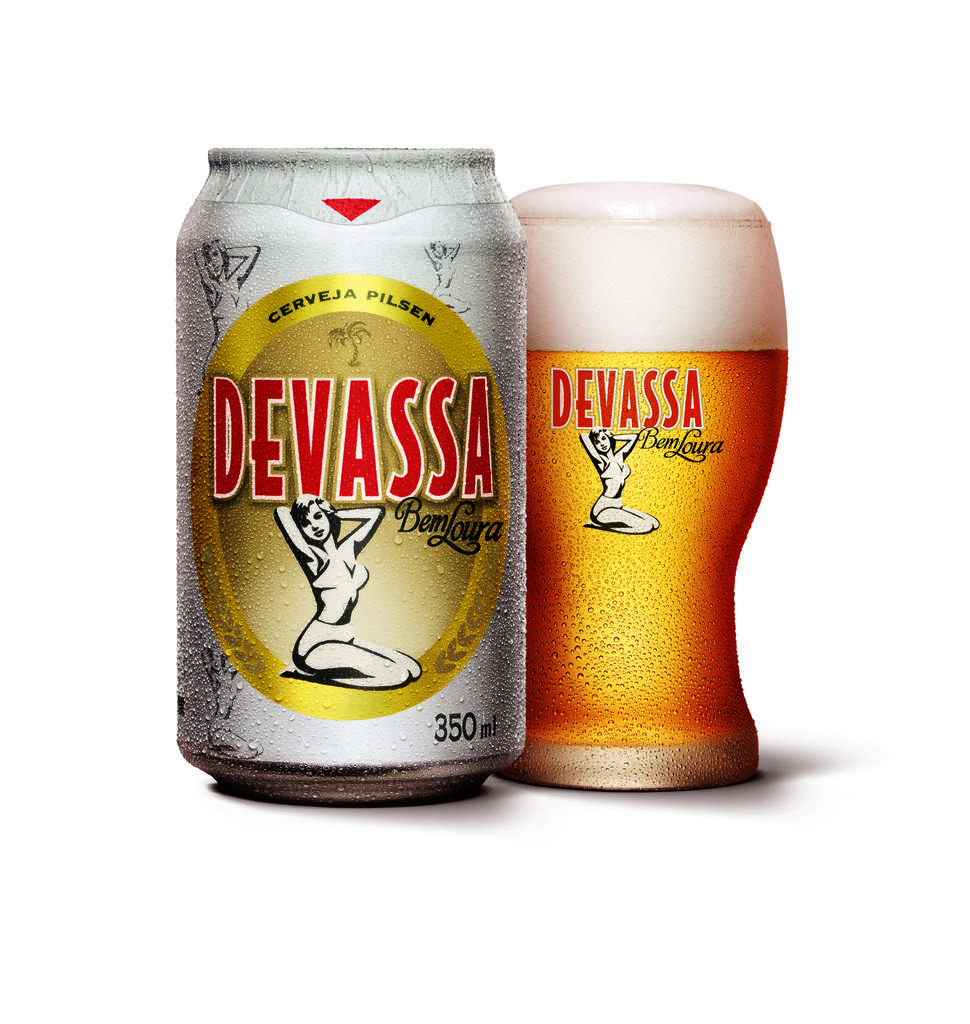What is the main object visible in the image? There is a glass in the image. What other object can be seen in the image? There is a tin with text and numbers written on it in the image. How many sheep are visible in the image? There are no sheep present in the image. What type of rings can be seen on the glass in the image? There are no rings visible on the glass in the image. 